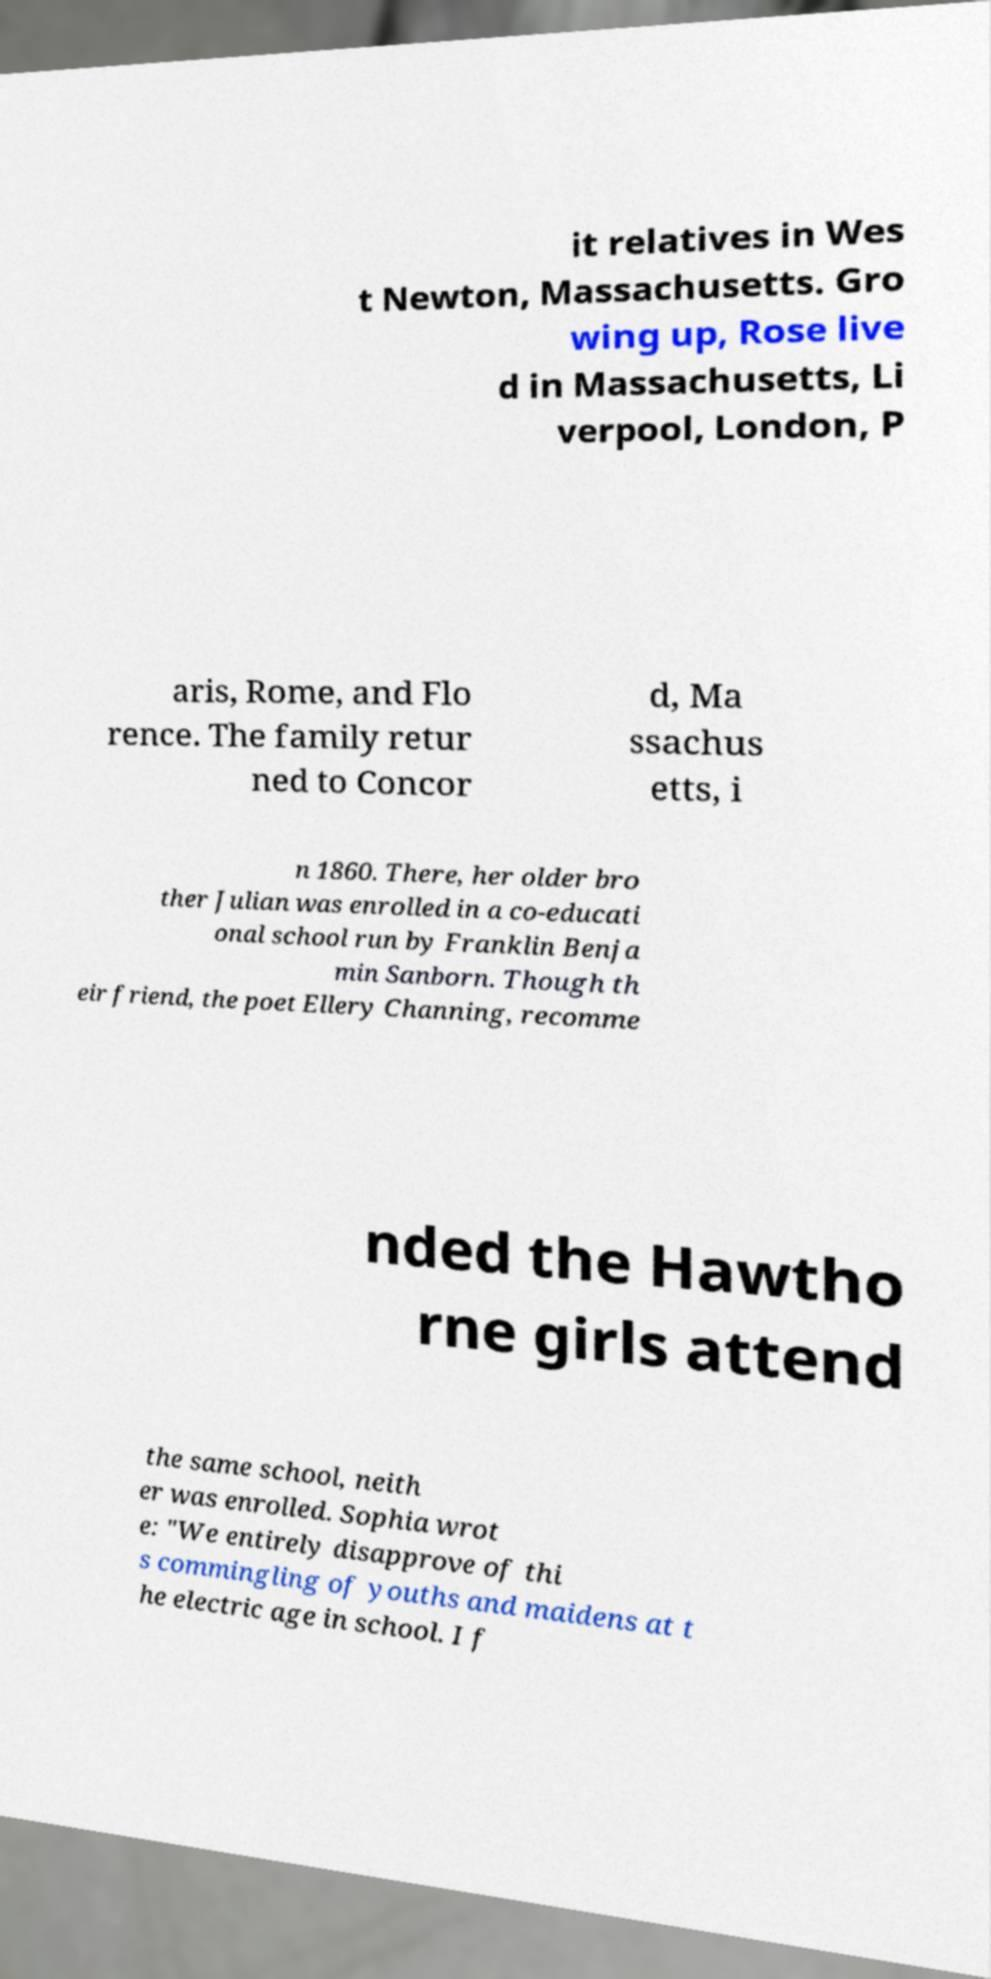Please read and relay the text visible in this image. What does it say? it relatives in Wes t Newton, Massachusetts. Gro wing up, Rose live d in Massachusetts, Li verpool, London, P aris, Rome, and Flo rence. The family retur ned to Concor d, Ma ssachus etts, i n 1860. There, her older bro ther Julian was enrolled in a co-educati onal school run by Franklin Benja min Sanborn. Though th eir friend, the poet Ellery Channing, recomme nded the Hawtho rne girls attend the same school, neith er was enrolled. Sophia wrot e: "We entirely disapprove of thi s commingling of youths and maidens at t he electric age in school. I f 